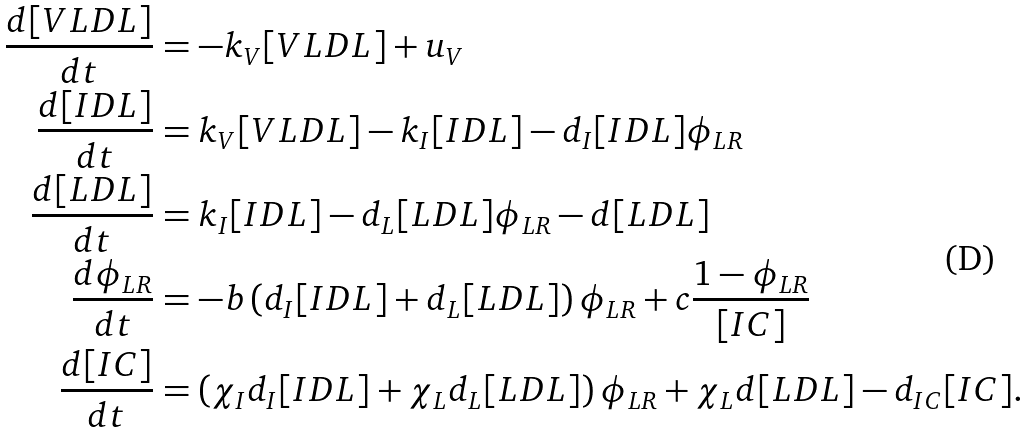<formula> <loc_0><loc_0><loc_500><loc_500>\frac { d [ V L D L ] } { d t } & = - k _ { V } [ V L D L ] + u _ { V } \\ \frac { d [ I D L ] } { d t } & = k _ { V } [ V L D L ] - k _ { I } [ I D L ] - d _ { I } [ I D L ] \phi _ { L R } \\ \frac { d [ L D L ] } { d t } & = k _ { I } [ I D L ] - d _ { L } [ L D L ] \phi _ { L R } - d [ L D L ] \\ \frac { d \phi _ { L R } } { d t } & = - b \left ( d _ { I } [ I D L ] + d _ { L } [ L D L ] \right ) \phi _ { L R } + c \frac { 1 - \phi _ { L R } } { [ I C ] } \\ \frac { d [ I C ] } { d t } & = \left ( \chi _ { I } d _ { I } [ I D L ] + \chi _ { L } d _ { L } [ L D L ] \right ) \phi _ { L R } + \chi _ { L } d [ L D L ] - d _ { I C } [ I C ] .</formula> 